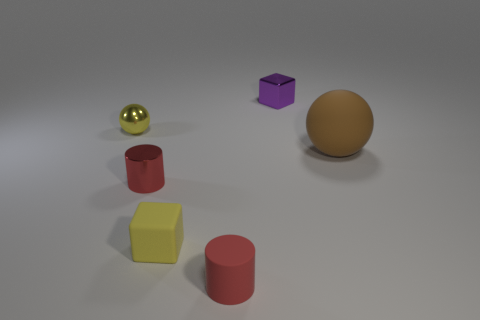Add 1 big green rubber blocks. How many objects exist? 7 Subtract all cylinders. How many objects are left? 4 Add 6 gray balls. How many gray balls exist? 6 Subtract 0 purple cylinders. How many objects are left? 6 Subtract all purple cylinders. Subtract all blue spheres. How many cylinders are left? 2 Subtract all small purple things. Subtract all red cylinders. How many objects are left? 3 Add 2 small yellow metallic things. How many small yellow metallic things are left? 3 